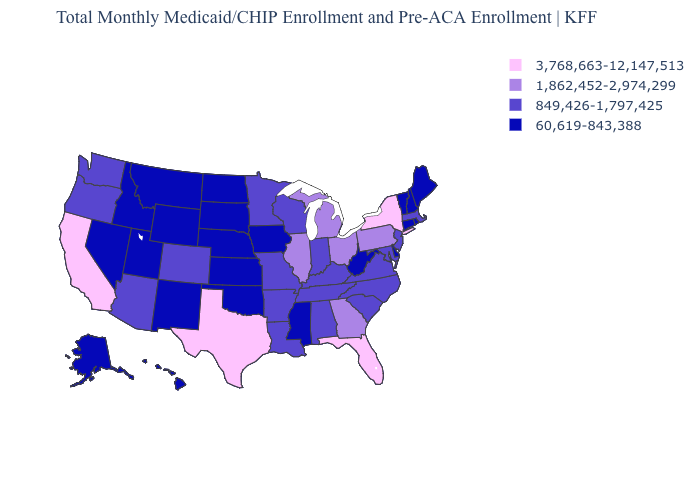Name the states that have a value in the range 3,768,663-12,147,513?
Concise answer only. California, Florida, New York, Texas. Does the first symbol in the legend represent the smallest category?
Keep it brief. No. What is the value of Tennessee?
Quick response, please. 849,426-1,797,425. What is the value of Maine?
Quick response, please. 60,619-843,388. Among the states that border New Jersey , which have the lowest value?
Concise answer only. Delaware. What is the value of Kansas?
Keep it brief. 60,619-843,388. Does Alaska have the lowest value in the West?
Be succinct. Yes. Does New Mexico have a lower value than Michigan?
Answer briefly. Yes. Among the states that border Vermont , does New Hampshire have the lowest value?
Answer briefly. Yes. What is the value of Minnesota?
Be succinct. 849,426-1,797,425. Which states hav the highest value in the South?
Give a very brief answer. Florida, Texas. What is the value of West Virginia?
Be succinct. 60,619-843,388. Does Kansas have the lowest value in the USA?
Write a very short answer. Yes. What is the value of Montana?
Be succinct. 60,619-843,388. What is the value of Nevada?
Be succinct. 60,619-843,388. 